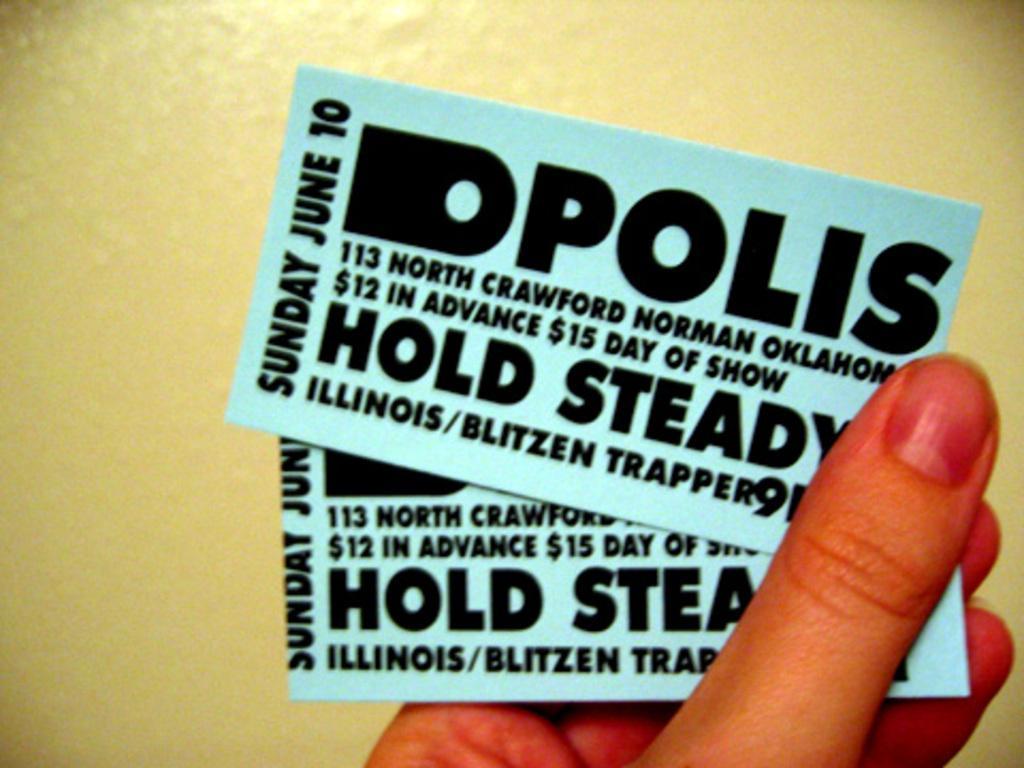Could you give a brief overview of what you see in this image? In this image we can see a person's hand holding tickets. In the background there is a wall. 